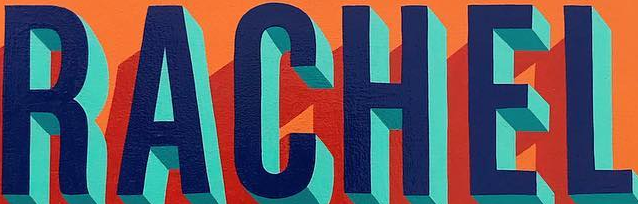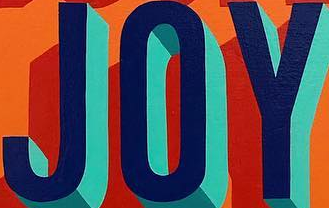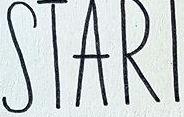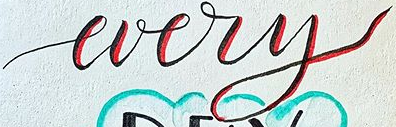Transcribe the words shown in these images in order, separated by a semicolon. RACHEL; JOY; STARI; every 